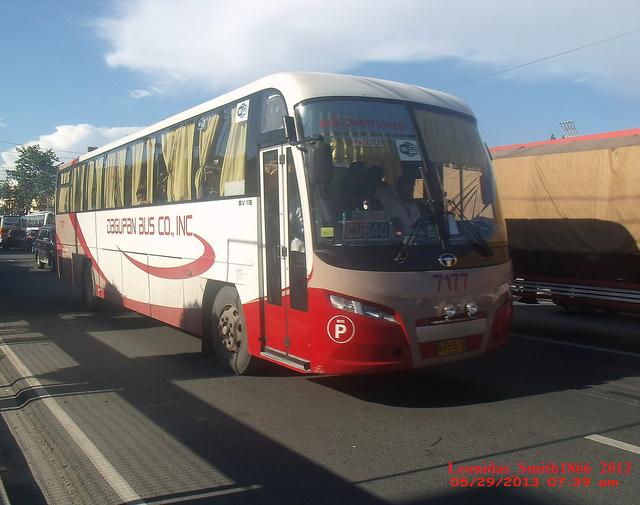Is this a school bus?
Quick response, please. No. Is there traffic?
Write a very short answer. Yes. What color is the bottom of the bus?
Short answer required. Red. What is the name of the bus company?
Keep it brief. Bus co inc. What company logo is on the top left of the truck window?
Write a very short answer. None. 